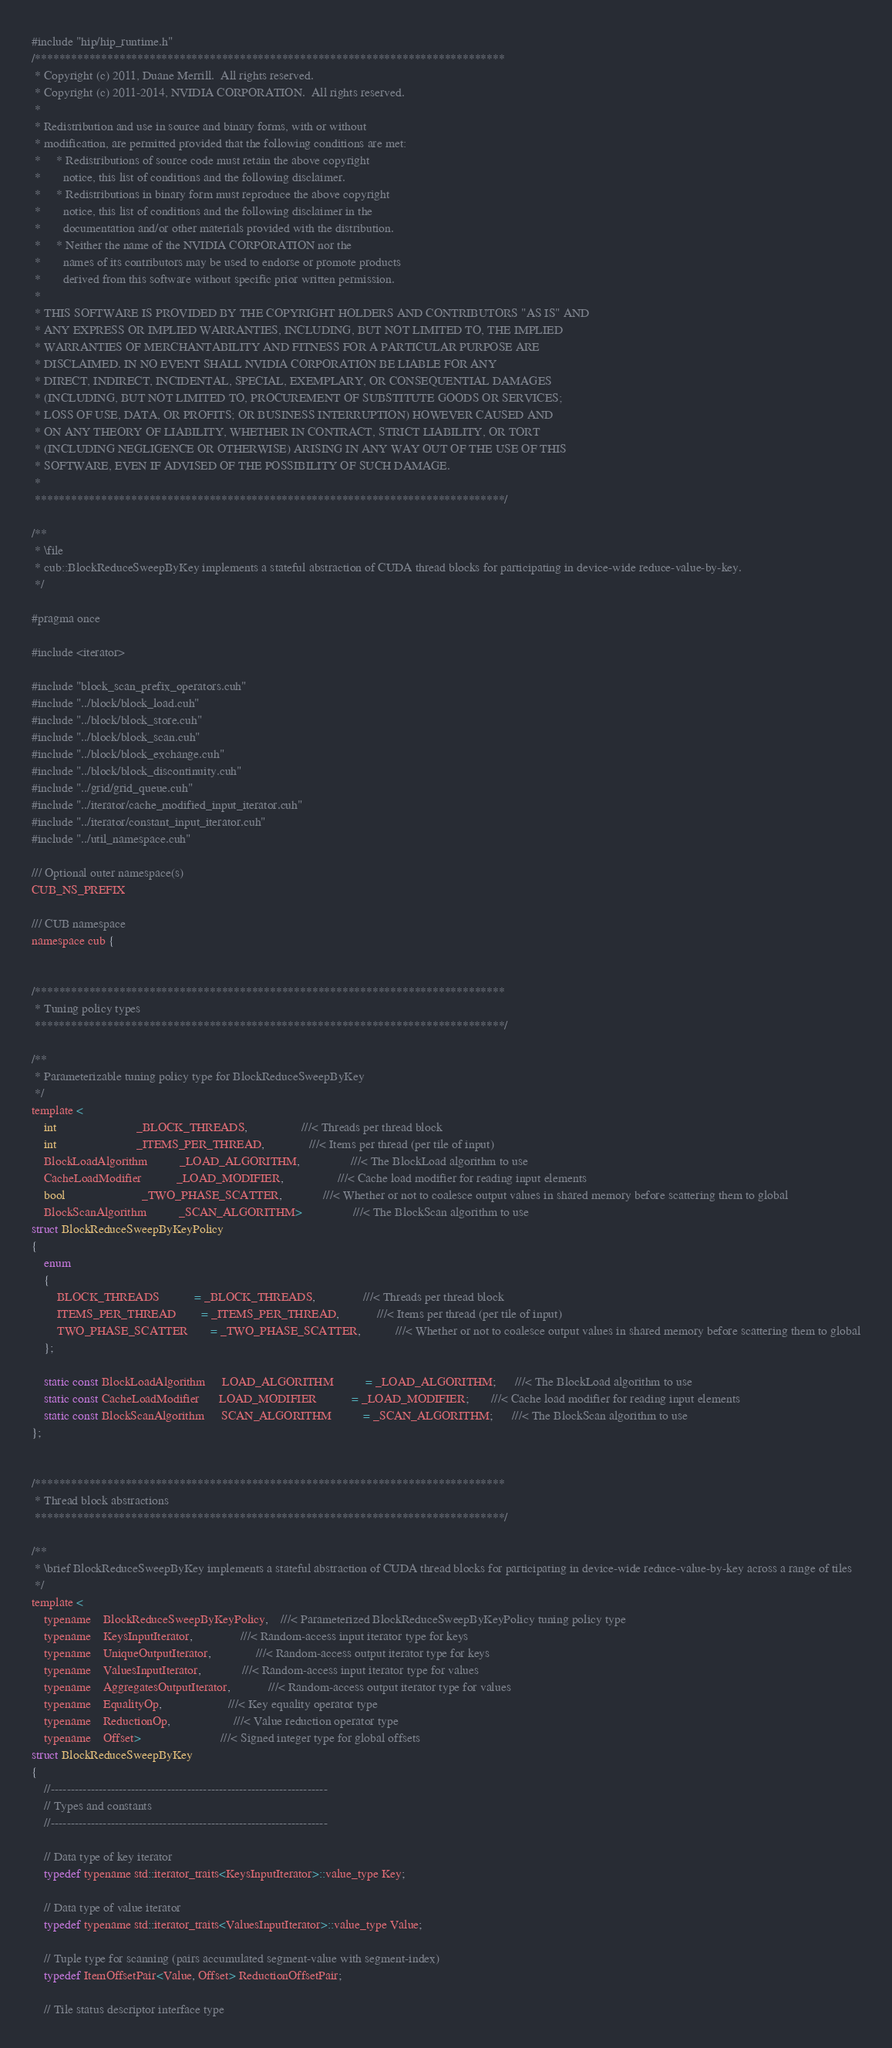<code> <loc_0><loc_0><loc_500><loc_500><_Cuda_>#include "hip/hip_runtime.h"
/******************************************************************************
 * Copyright (c) 2011, Duane Merrill.  All rights reserved.
 * Copyright (c) 2011-2014, NVIDIA CORPORATION.  All rights reserved.
 *
 * Redistribution and use in source and binary forms, with or without
 * modification, are permitted provided that the following conditions are met:
 *     * Redistributions of source code must retain the above copyright
 *       notice, this list of conditions and the following disclaimer.
 *     * Redistributions in binary form must reproduce the above copyright
 *       notice, this list of conditions and the following disclaimer in the
 *       documentation and/or other materials provided with the distribution.
 *     * Neither the name of the NVIDIA CORPORATION nor the
 *       names of its contributors may be used to endorse or promote products
 *       derived from this software without specific prior written permission.
 *
 * THIS SOFTWARE IS PROVIDED BY THE COPYRIGHT HOLDERS AND CONTRIBUTORS "AS IS" AND
 * ANY EXPRESS OR IMPLIED WARRANTIES, INCLUDING, BUT NOT LIMITED TO, THE IMPLIED
 * WARRANTIES OF MERCHANTABILITY AND FITNESS FOR A PARTICULAR PURPOSE ARE
 * DISCLAIMED. IN NO EVENT SHALL NVIDIA CORPORATION BE LIABLE FOR ANY
 * DIRECT, INDIRECT, INCIDENTAL, SPECIAL, EXEMPLARY, OR CONSEQUENTIAL DAMAGES
 * (INCLUDING, BUT NOT LIMITED TO, PROCUREMENT OF SUBSTITUTE GOODS OR SERVICES;
 * LOSS OF USE, DATA, OR PROFITS; OR BUSINESS INTERRUPTION) HOWEVER CAUSED AND
 * ON ANY THEORY OF LIABILITY, WHETHER IN CONTRACT, STRICT LIABILITY, OR TORT
 * (INCLUDING NEGLIGENCE OR OTHERWISE) ARISING IN ANY WAY OUT OF THE USE OF THIS
 * SOFTWARE, EVEN IF ADVISED OF THE POSSIBILITY OF SUCH DAMAGE.
 *
 ******************************************************************************/

/**
 * \file
 * cub::BlockReduceSweepByKey implements a stateful abstraction of CUDA thread blocks for participating in device-wide reduce-value-by-key.
 */

#pragma once

#include <iterator>

#include "block_scan_prefix_operators.cuh"
#include "../block/block_load.cuh"
#include "../block/block_store.cuh"
#include "../block/block_scan.cuh"
#include "../block/block_exchange.cuh"
#include "../block/block_discontinuity.cuh"
#include "../grid/grid_queue.cuh"
#include "../iterator/cache_modified_input_iterator.cuh"
#include "../iterator/constant_input_iterator.cuh"
#include "../util_namespace.cuh"

/// Optional outer namespace(s)
CUB_NS_PREFIX

/// CUB namespace
namespace cub {


/******************************************************************************
 * Tuning policy types
 ******************************************************************************/

/**
 * Parameterizable tuning policy type for BlockReduceSweepByKey
 */
template <
    int                         _BLOCK_THREADS,                 ///< Threads per thread block
    int                         _ITEMS_PER_THREAD,              ///< Items per thread (per tile of input)
    BlockLoadAlgorithm          _LOAD_ALGORITHM,                ///< The BlockLoad algorithm to use
    CacheLoadModifier           _LOAD_MODIFIER,                 ///< Cache load modifier for reading input elements
    bool                        _TWO_PHASE_SCATTER,             ///< Whether or not to coalesce output values in shared memory before scattering them to global
    BlockScanAlgorithm          _SCAN_ALGORITHM>                ///< The BlockScan algorithm to use
struct BlockReduceSweepByKeyPolicy
{
    enum
    {
        BLOCK_THREADS           = _BLOCK_THREADS,               ///< Threads per thread block
        ITEMS_PER_THREAD        = _ITEMS_PER_THREAD,            ///< Items per thread (per tile of input)
        TWO_PHASE_SCATTER       = _TWO_PHASE_SCATTER,           ///< Whether or not to coalesce output values in shared memory before scattering them to global
    };

    static const BlockLoadAlgorithm     LOAD_ALGORITHM          = _LOAD_ALGORITHM;      ///< The BlockLoad algorithm to use
    static const CacheLoadModifier      LOAD_MODIFIER           = _LOAD_MODIFIER;       ///< Cache load modifier for reading input elements
    static const BlockScanAlgorithm     SCAN_ALGORITHM          = _SCAN_ALGORITHM;      ///< The BlockScan algorithm to use
};


/******************************************************************************
 * Thread block abstractions
 ******************************************************************************/

/**
 * \brief BlockReduceSweepByKey implements a stateful abstraction of CUDA thread blocks for participating in device-wide reduce-value-by-key across a range of tiles
 */
template <
    typename    BlockReduceSweepByKeyPolicy,    ///< Parameterized BlockReduceSweepByKeyPolicy tuning policy type
    typename    KeysInputIterator,               ///< Random-access input iterator type for keys
    typename    UniqueOutputIterator,              ///< Random-access output iterator type for keys
    typename    ValuesInputIterator,             ///< Random-access input iterator type for values
    typename    AggregatesOutputIterator,            ///< Random-access output iterator type for values
    typename    EqualityOp,                     ///< Key equality operator type
    typename    ReductionOp,                    ///< Value reduction operator type
    typename    Offset>                         ///< Signed integer type for global offsets
struct BlockReduceSweepByKey
{
    //---------------------------------------------------------------------
    // Types and constants
    //---------------------------------------------------------------------

    // Data type of key iterator
    typedef typename std::iterator_traits<KeysInputIterator>::value_type Key;

    // Data type of value iterator
    typedef typename std::iterator_traits<ValuesInputIterator>::value_type Value;

    // Tuple type for scanning (pairs accumulated segment-value with segment-index)
    typedef ItemOffsetPair<Value, Offset> ReductionOffsetPair;

    // Tile status descriptor interface type</code> 